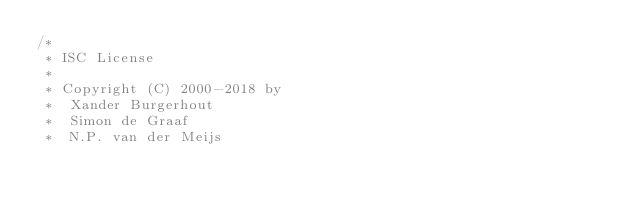Convert code to text. <code><loc_0><loc_0><loc_500><loc_500><_C++_>/*
 * ISC License
 *
 * Copyright (C) 2000-2018 by
 *	Xander Burgerhout
 *	Simon de Graaf
 *	N.P. van der Meijs</code> 